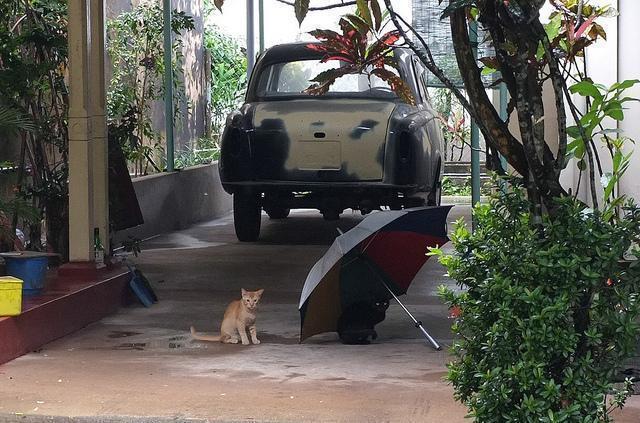What is under the umbrella?
Indicate the correct response by choosing from the four available options to answer the question.
Options: Baby, black cat, old woman, old man. Black cat. 